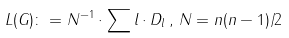Convert formula to latex. <formula><loc_0><loc_0><loc_500><loc_500>L ( G ) \colon = N ^ { - 1 } \cdot \sum l \cdot D _ { l } \, , \, N = n ( n - 1 ) / 2</formula> 